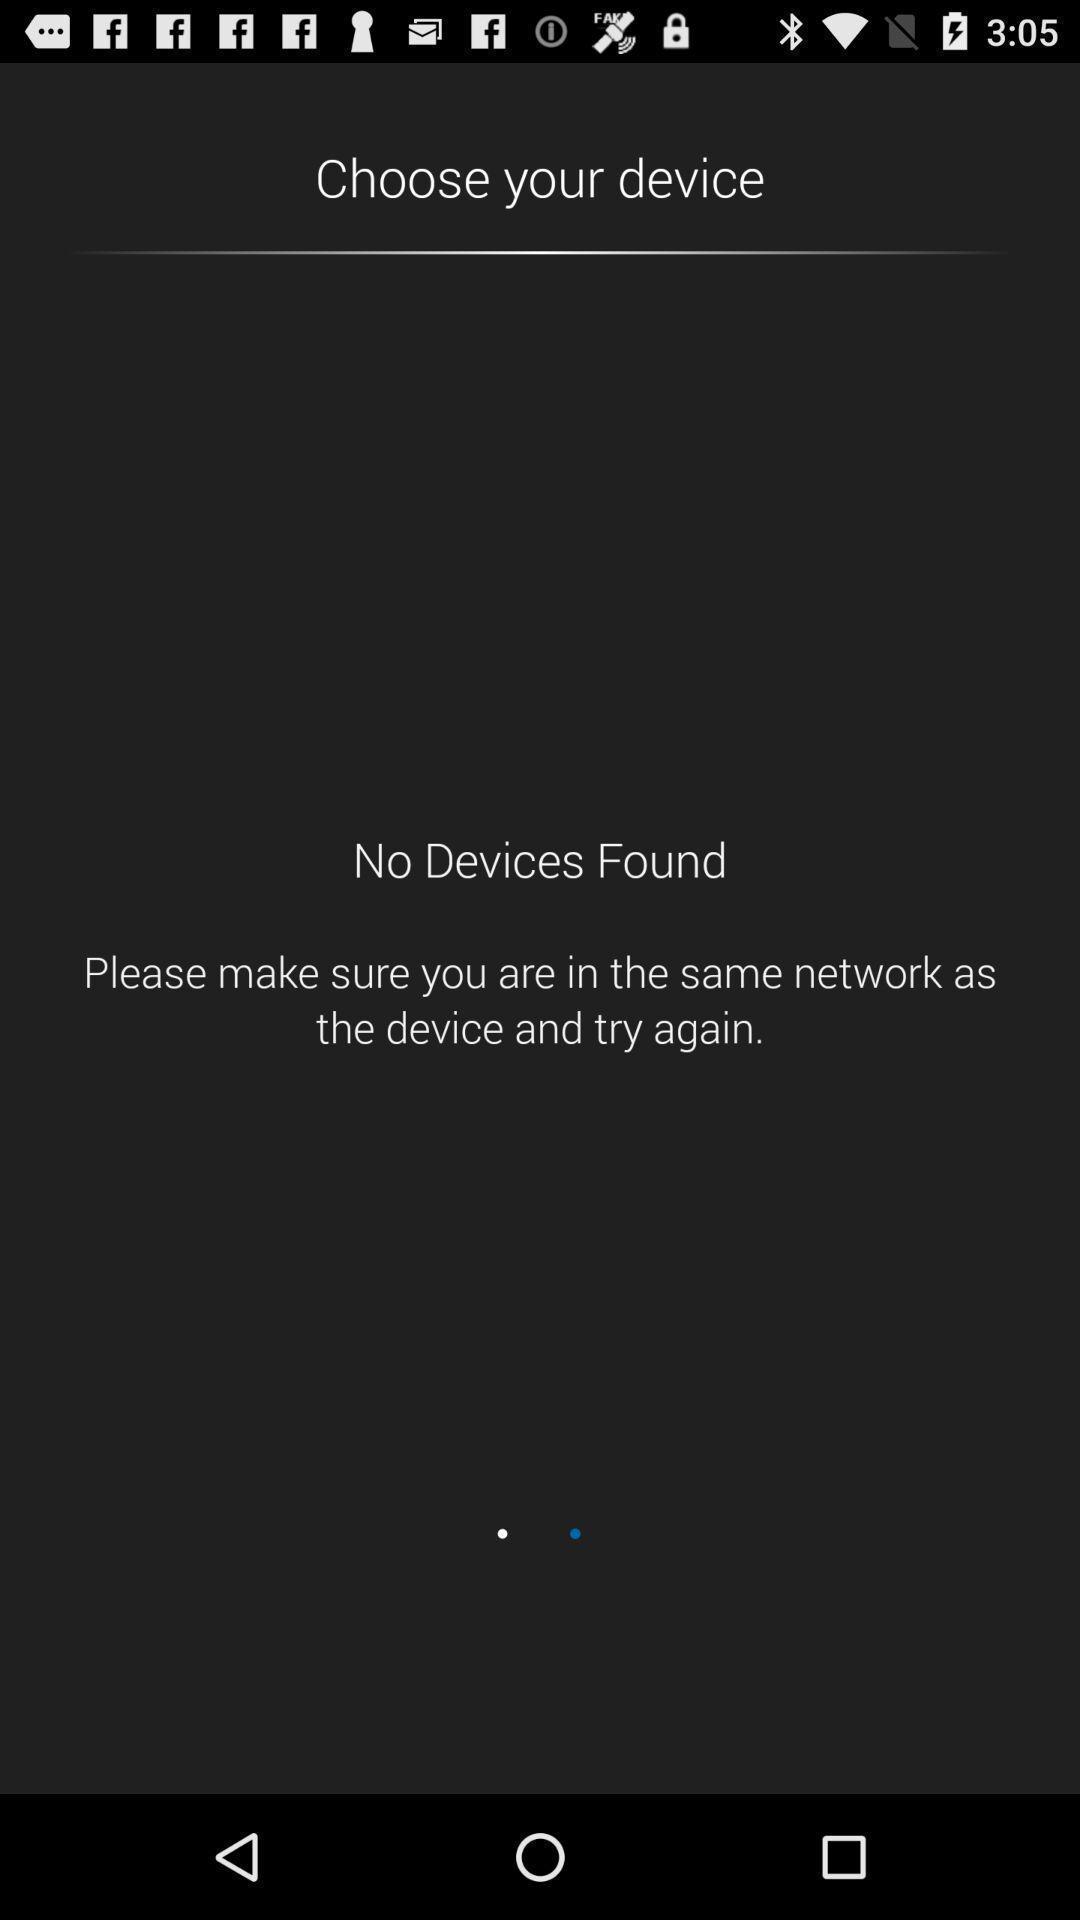What details can you identify in this image? Page showing no devices found. 